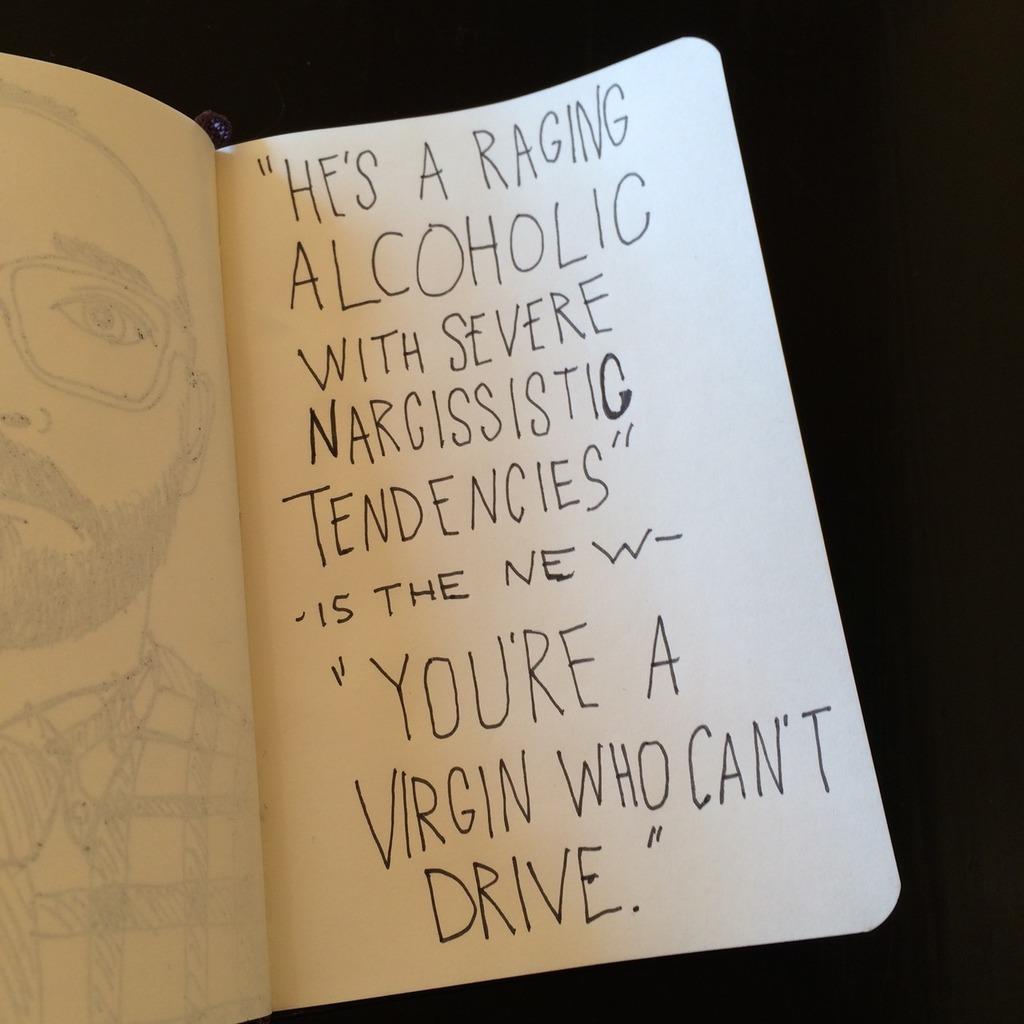The person say that "he" is a what?
Your answer should be compact. Raging alcoholic. You're a what who can't what?
Your answer should be very brief. You're a virgin who can't drive. 